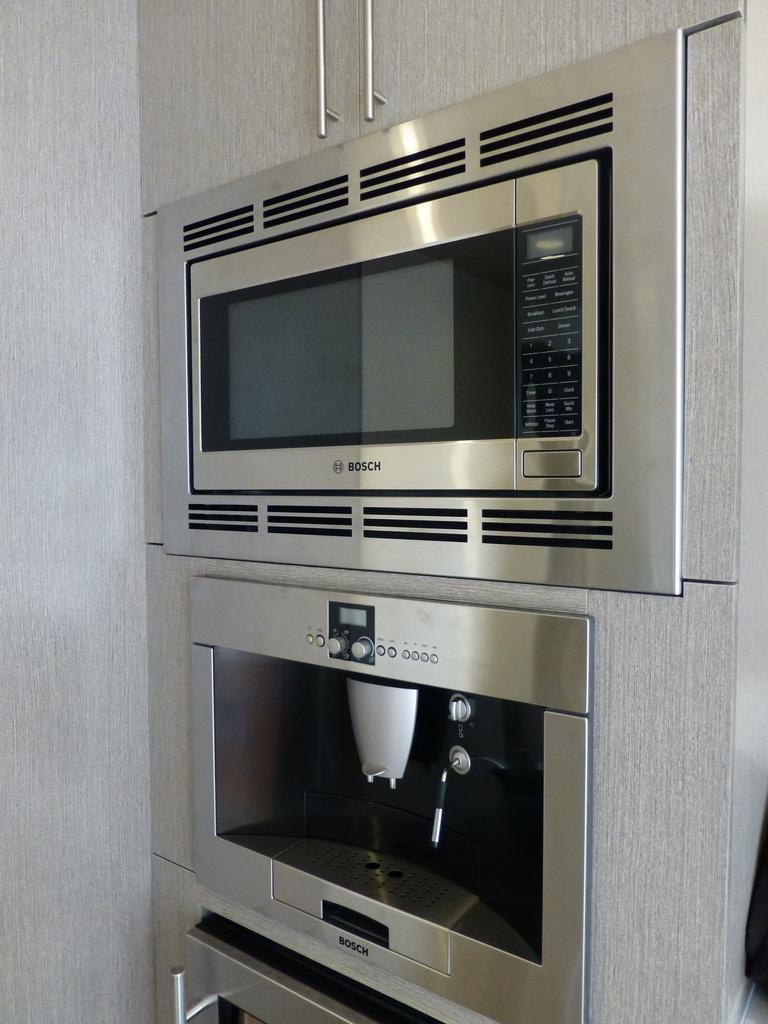In one or two sentences, can you explain what this image depicts? In this image I can see there is a cupboard. And there is a micro oven placed in it. And at the side, it looks like a cloth. 